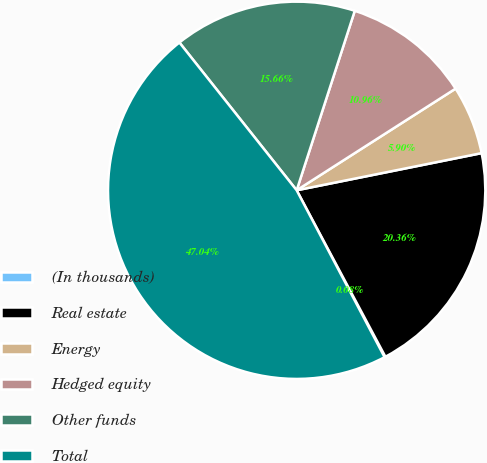<chart> <loc_0><loc_0><loc_500><loc_500><pie_chart><fcel>(In thousands)<fcel>Real estate<fcel>Energy<fcel>Hedged equity<fcel>Other funds<fcel>Total<nl><fcel>0.08%<fcel>20.36%<fcel>5.9%<fcel>10.96%<fcel>15.66%<fcel>47.04%<nl></chart> 